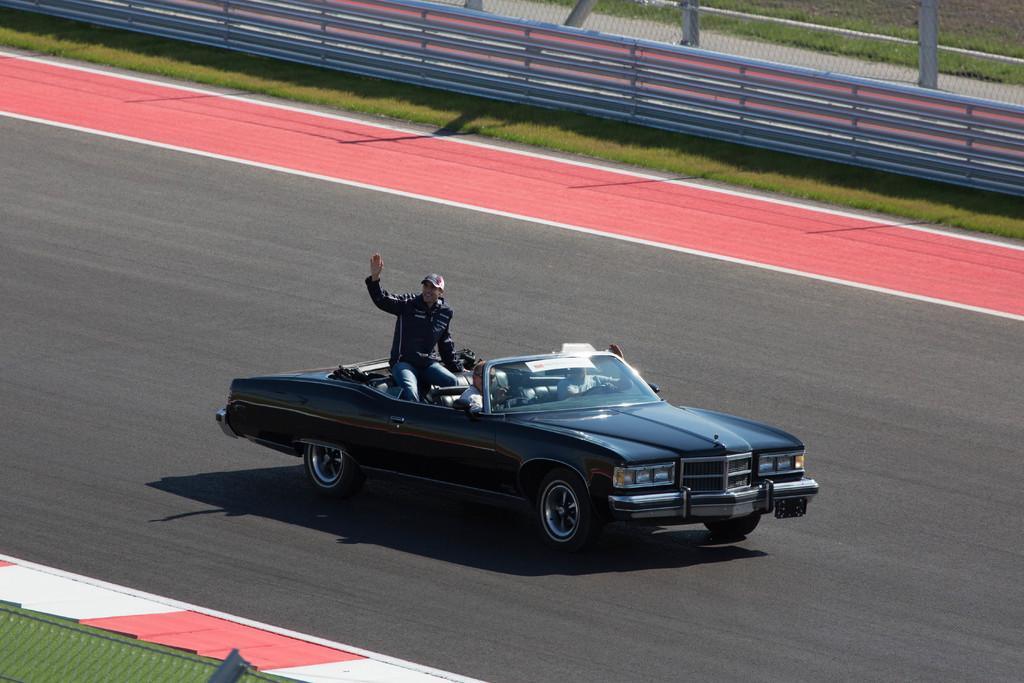Can you describe this image briefly? In this image I can see the car on the road. I can see few people inside the car with different color dresses and one person is wearing the cap. To the side of the road there is a railing, poles and the grass. 